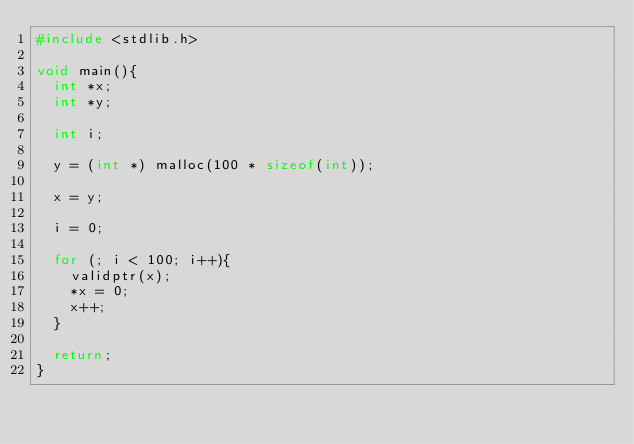Convert code to text. <code><loc_0><loc_0><loc_500><loc_500><_C_>#include <stdlib.h>

void main(){
  int *x;
  int *y;

  int i;

  y = (int *) malloc(100 * sizeof(int));
  
  x = y;

  i = 0;
  
  for (; i < 100; i++){  
    validptr(x);
    *x = 0;
    x++;
  }

  return;
}
</code> 